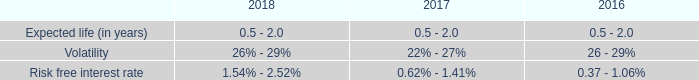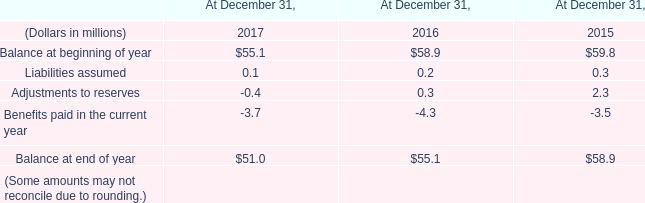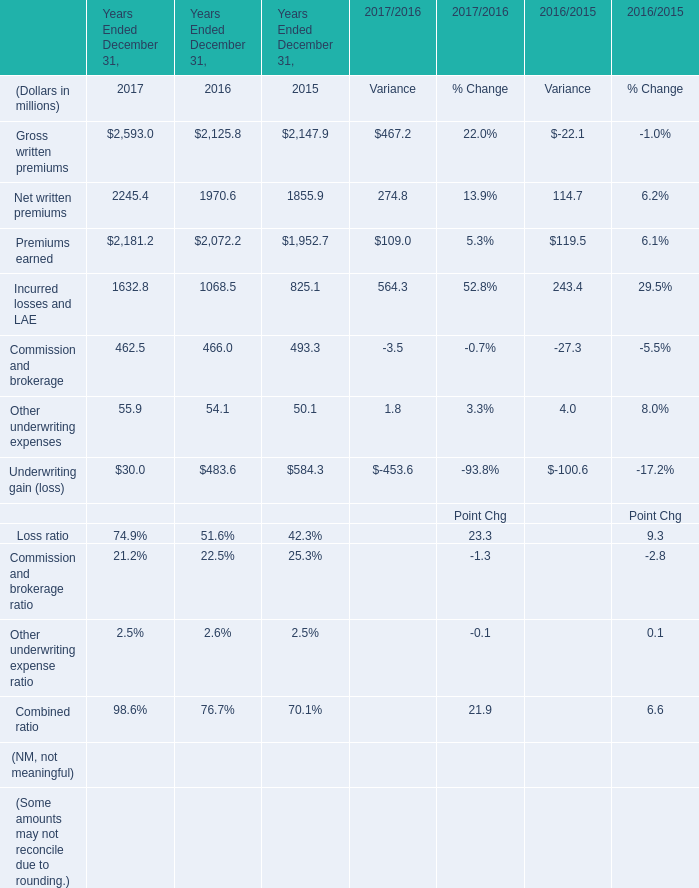What is the total value of Net written premiums, Premiums earned, Incurred losses and LAE and Commission and brokerage in 2016 ? (in million) 
Computations: (((1970.6 + 2072.2) + 1068.5) + 466)
Answer: 5577.3. 